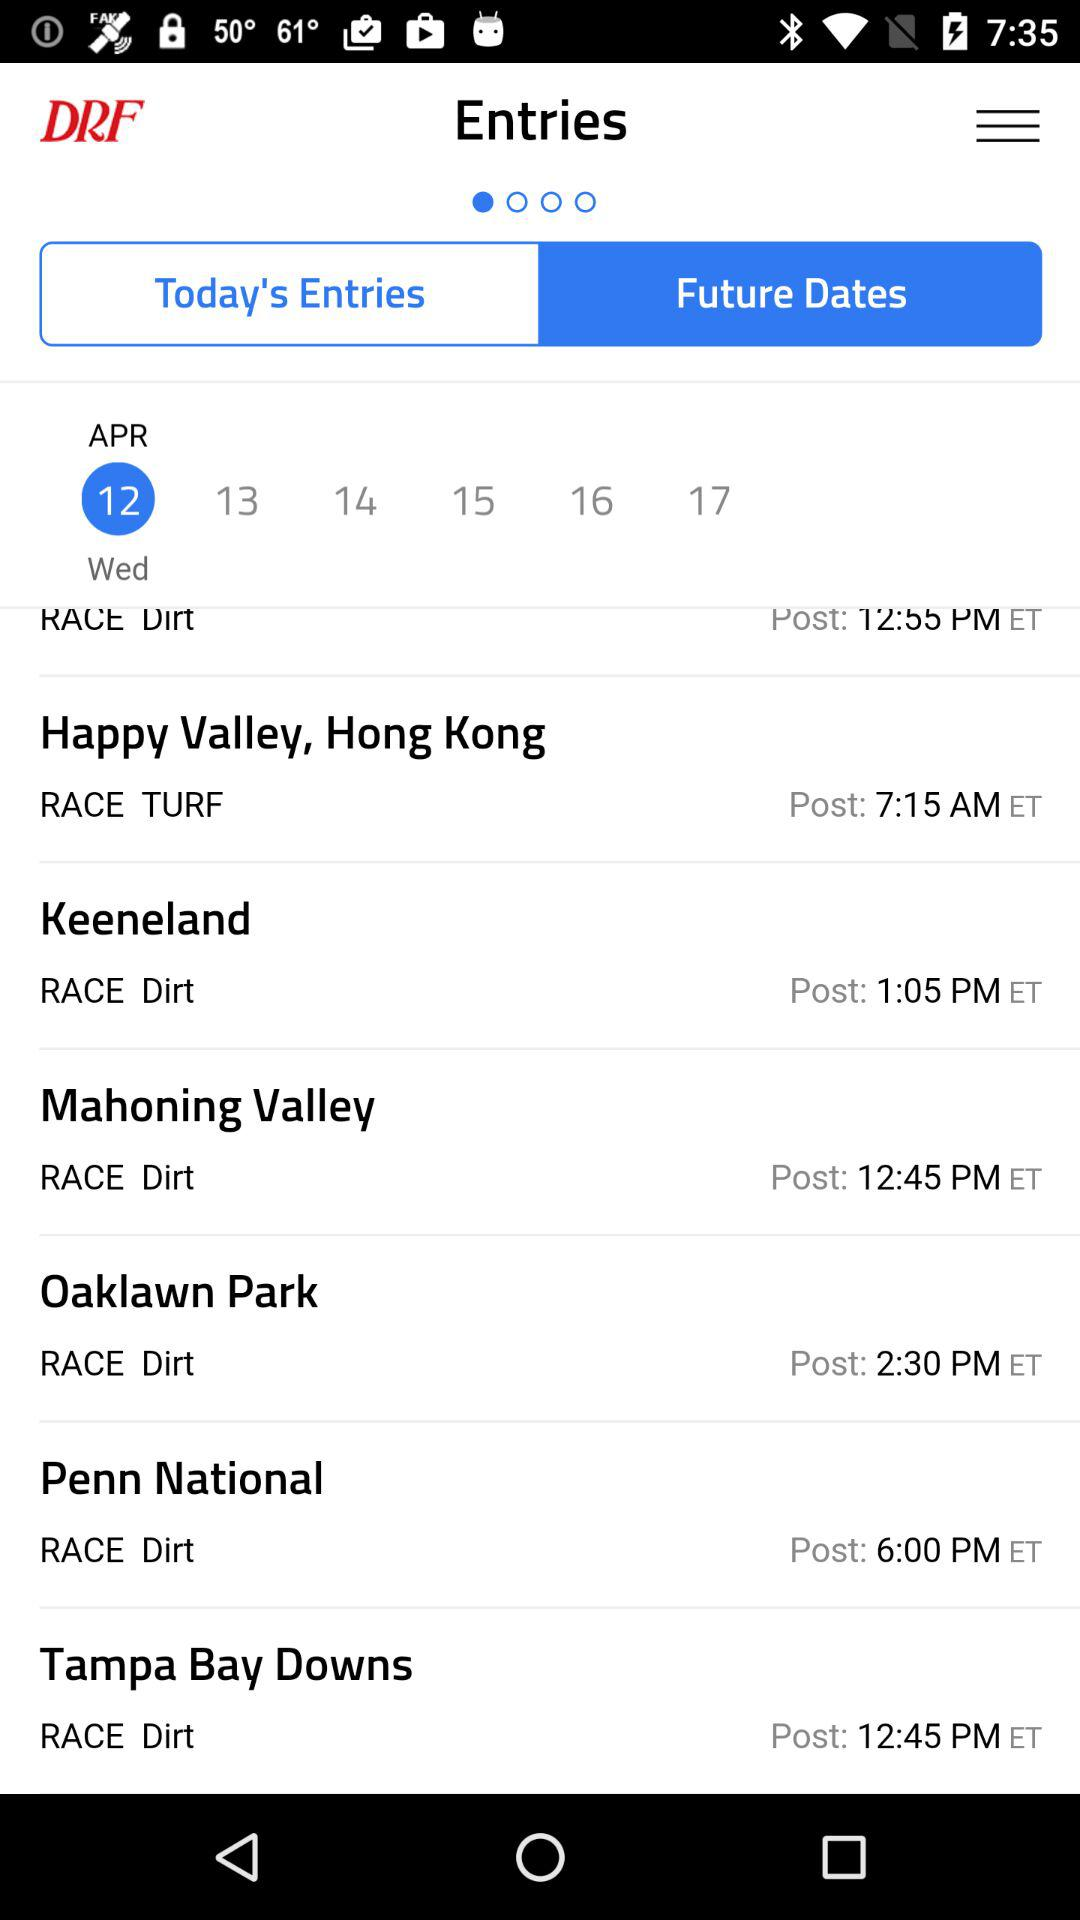What is the post time of the Tampa Bay Downs? The post time is 12:45 PM ET. 